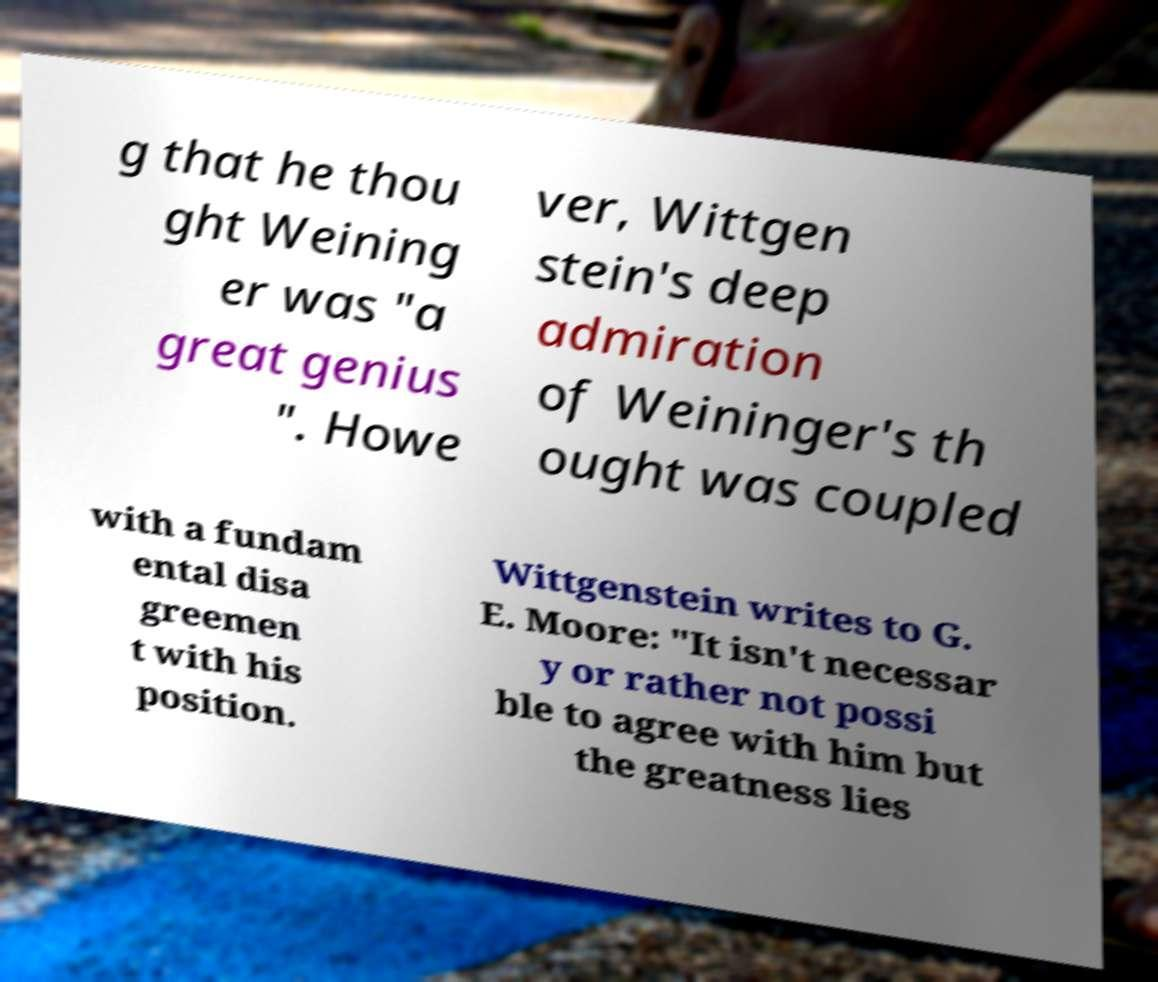Please identify and transcribe the text found in this image. g that he thou ght Weining er was "a great genius ". Howe ver, Wittgen stein's deep admiration of Weininger's th ought was coupled with a fundam ental disa greemen t with his position. Wittgenstein writes to G. E. Moore: "It isn't necessar y or rather not possi ble to agree with him but the greatness lies 